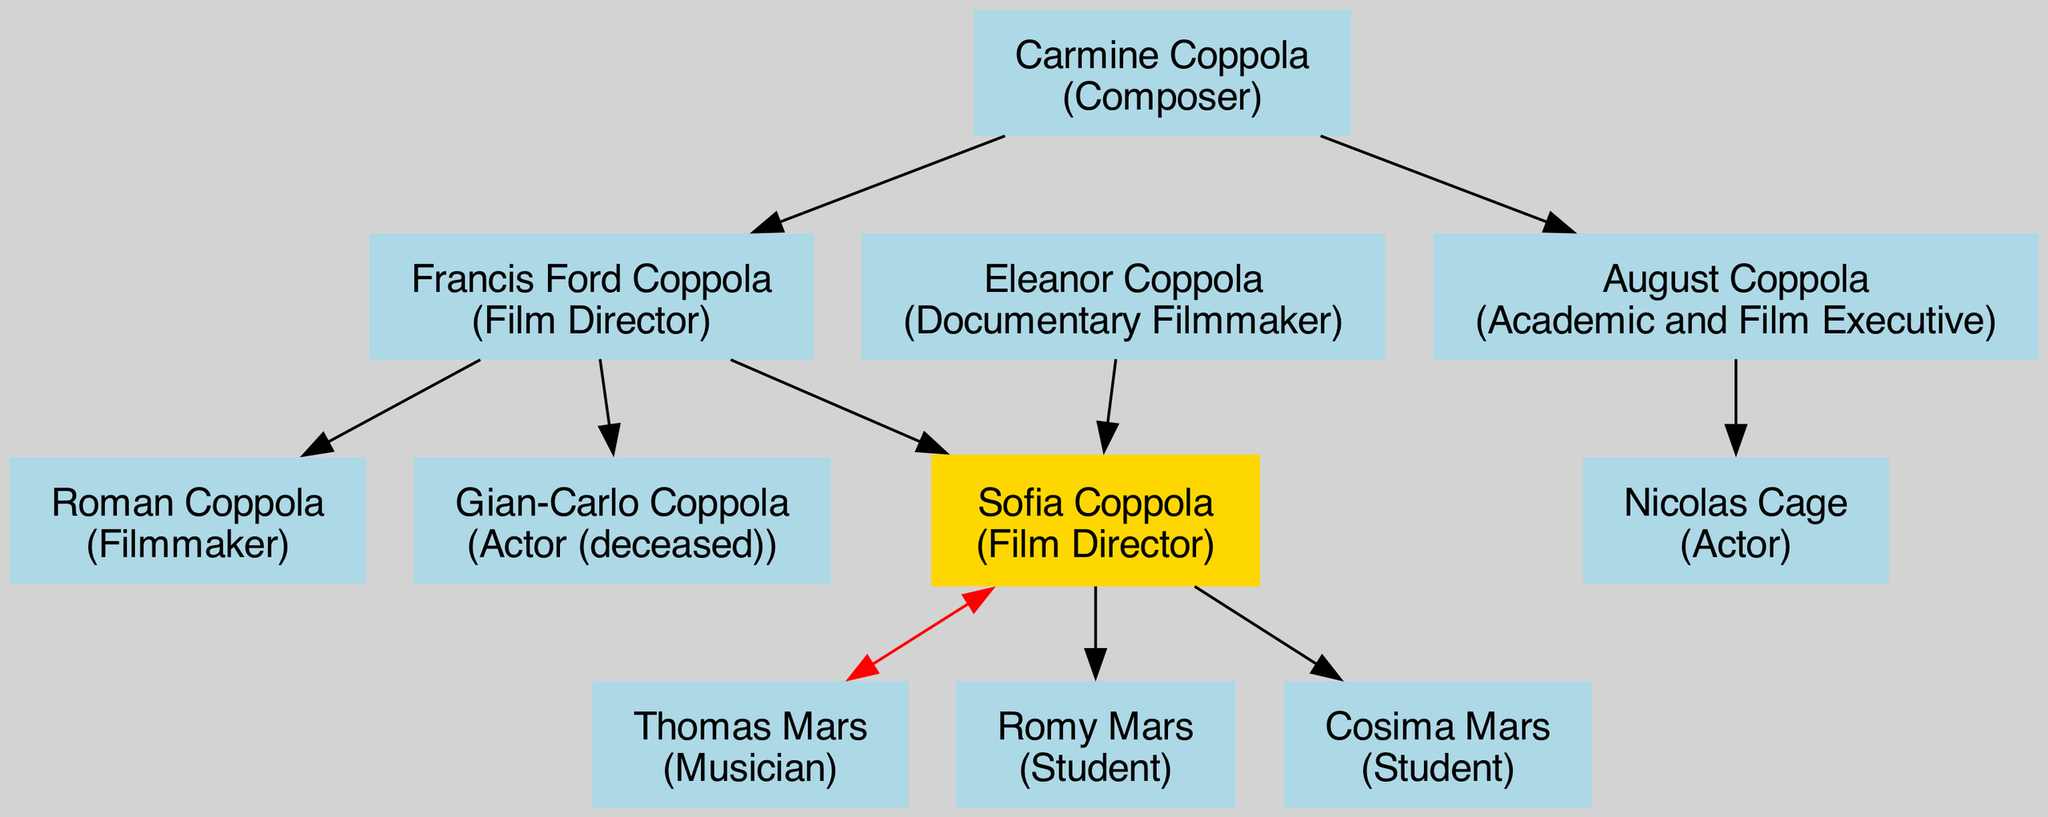What is Sofia Coppola's occupation? The diagram indicates that Sofia Coppola is identified as a film director. This information is presented in the node representing her.
Answer: Film Director Who is Sofia's uncle? The diagram shows that Sofia's uncle is August Coppola. This relationship is detailed in the connection made in the family tree.
Answer: August Coppola How many siblings does Sofia have? In the diagram, Sofia is represented with two siblings: Roman Coppola and Gian-Carlo Coppola. Therefore, when counting, there are two siblings shown.
Answer: 2 What is the occupation of Sofia's father? The diagram specifies that Sofia's father is Francis Ford Coppola, who is also a film director. This is denoted in the respective node for her father.
Answer: Film Director Who is Nicolas Cage in relation to Sofia? The diagram reveals that Nicolas Cage is Sofia's cousin, which is connected through their shared uncle, August Coppola.
Answer: Cousin Which family members are also involved in the arts or entertainment industry? The diagram identifies multiple family members in the arts: Sofia Coppola (Film Director), Francis Ford Coppola (Film Director), Eleanor Coppola (Documentary Filmmaker), Roman Coppola (Filmmaker), Gian-Carlo Coppola (Actor), August Coppola (Film Executive), Nicolas Cage (Actor), and Carmine Coppola (Composer). Therefore, the query highlights numerous individuals from the arts within her family.
Answer: 8 What is Sofia Coppola's spouse's occupation? According to the diagram, Thomas Mars, identified as Sofia's spouse, is a musician. This is specified in the connecting line between them and illustrated in his node.
Answer: Musician How are Sofia and her children related? The family tree illustrates that Sofia is connected to her children, Romy Mars and Cosima Mars, indicating a parent-child relationship. In this case, Sofia is their mother, thereby establishing their familial connection.
Answer: Mother-Child Relationship 